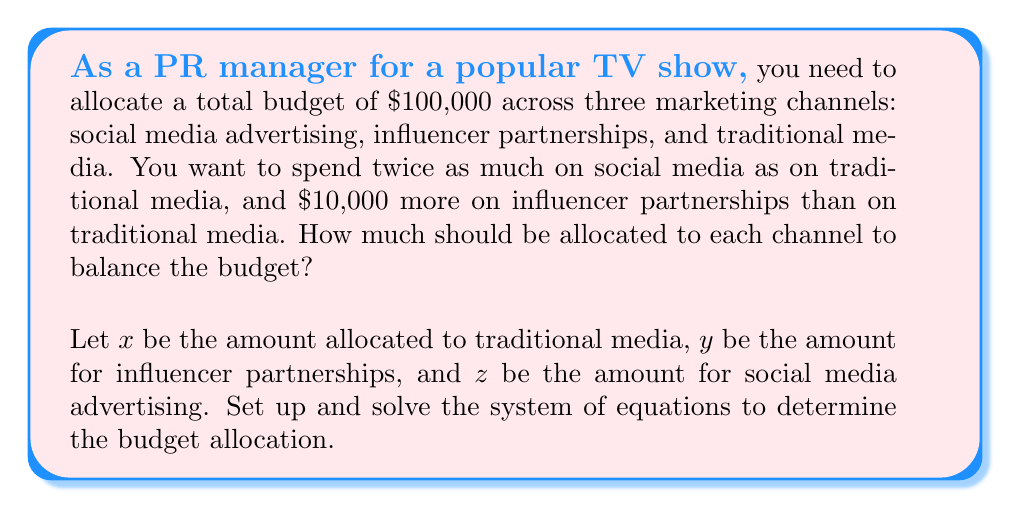What is the answer to this math problem? Let's solve this step-by-step:

1) First, we set up our system of equations based on the given information:

   $$x + y + z = 100000$$ (total budget)
   $$z = 2x$$ (social media is twice traditional media)
   $$y = x + 10000$$ (influencer partnerships is $10,000 more than traditional media)

2) Substitute the expressions for $y$ and $z$ into the first equation:

   $$x + (x + 10000) + 2x = 100000$$

3) Simplify:

   $$4x + 10000 = 100000$$

4) Subtract 10000 from both sides:

   $$4x = 90000$$

5) Divide both sides by 4:

   $$x = 22500$$

6) Now that we know $x$, we can find $y$ and $z$:

   $$y = x + 10000 = 22500 + 10000 = 32500$$
   $$z = 2x = 2(22500) = 45000$$

7) Verify that the sum equals the total budget:

   $$22500 + 32500 + 45000 = 100000$$

Therefore, the budget allocation should be:
- Traditional media: $22,500
- Influencer partnerships: $32,500
- Social media advertising: $45,000
Answer: Traditional media: $22,500; Influencer partnerships: $32,500; Social media: $45,000 